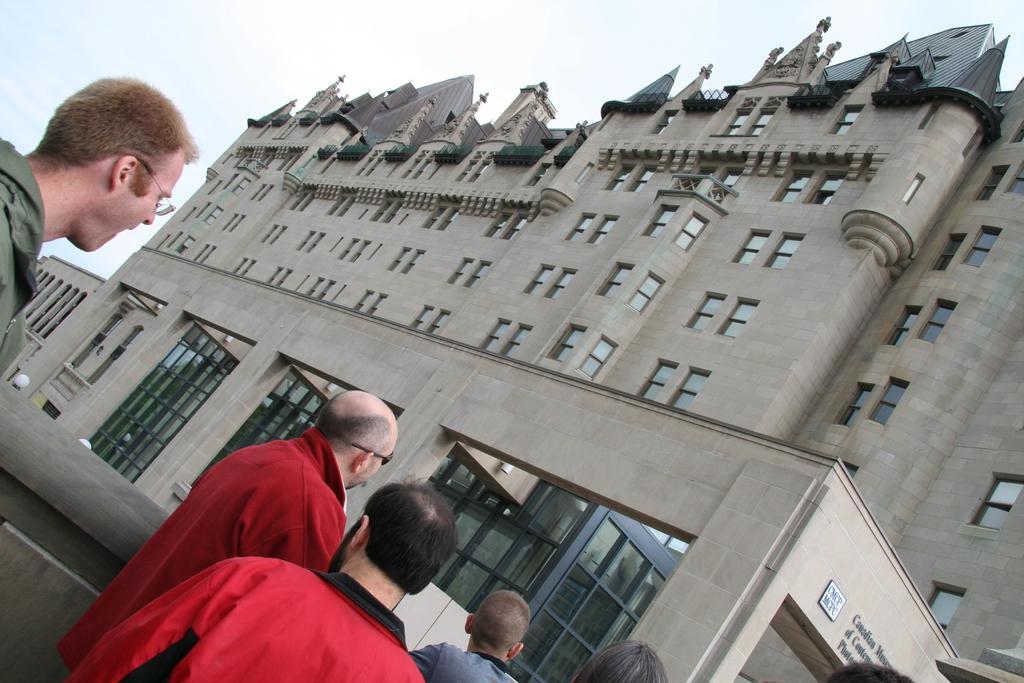In one or two sentences, can you explain what this image depicts? In this picture we can see a group of people standing, building with windows and in the background we can see the sky. 